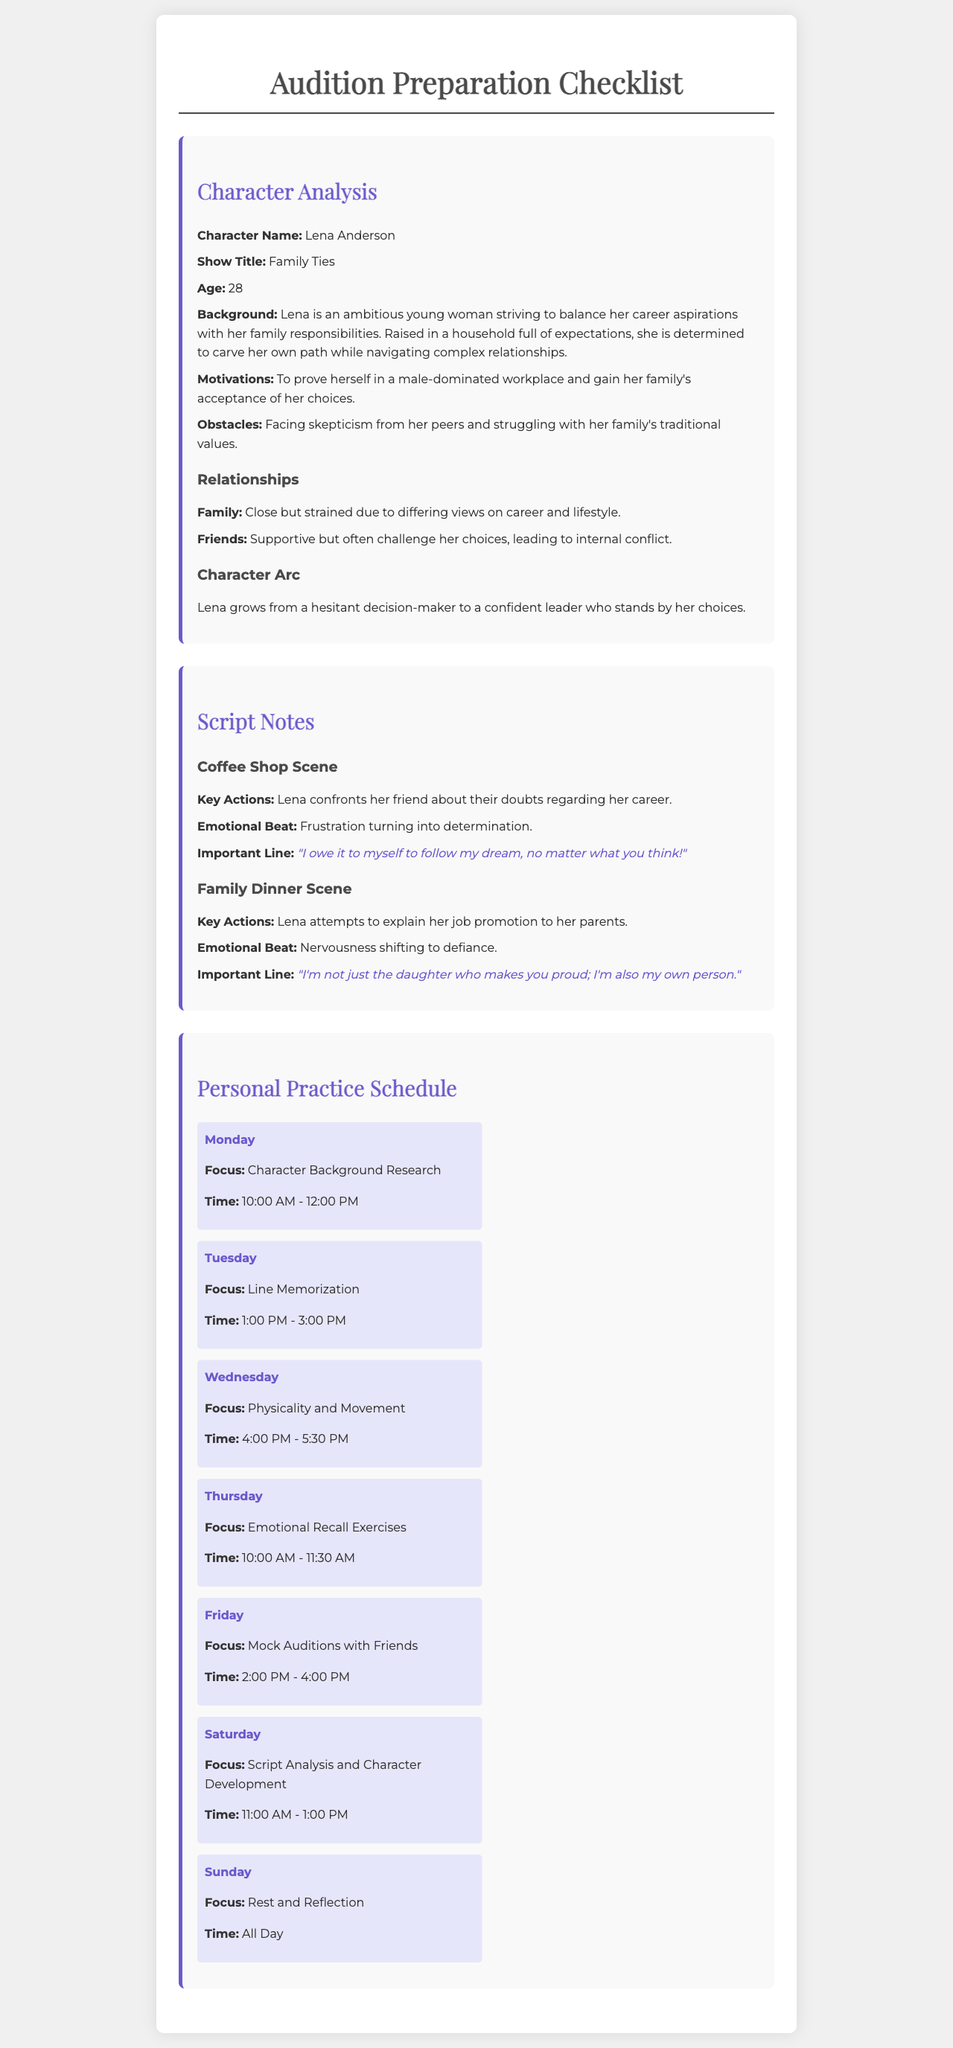What is the character name? The character name is stated clearly in the character analysis section.
Answer: Lena Anderson What is Lena's age? The age of Lena is provided within her character analysis.
Answer: 28 What is Lena's motivation? The motivation for Lena is outlined in her character analysis, showing her primary drive.
Answer: To prove herself in a male-dominated workplace and gain her family's acceptance of her choices What key action occurs in the coffee shop scene? The key action is explicitly described in the script notes for the coffee shop scene.
Answer: Lena confronts her friend about their doubts regarding her career What is the focus for Wednesdays in the personal practice schedule? The focus for Wednesdays can be found in the personal practice schedule section.
Answer: Physicality and Movement How long is the practice session for line memorization on Tuesday? The duration can be inferred from the time mentioned for that day's practice in the schedule.
Answer: 2 hours What does Lena's character arc emphasize? The character arc details provided highlight the progression of her character.
Answer: Lena grows from a hesitant decision-maker to a confident leader who stands by her choices What is the emotional beat of the family dinner scene? The emotional shift is indicated in the script notes in the family dinner section.
Answer: Nervousness shifting to defiance What is the key line from the coffee shop scene? The important line is highlighted specifically in the notes for the coffee shop scene.
Answer: "I owe it to myself to follow my dream, no matter what you think!" 